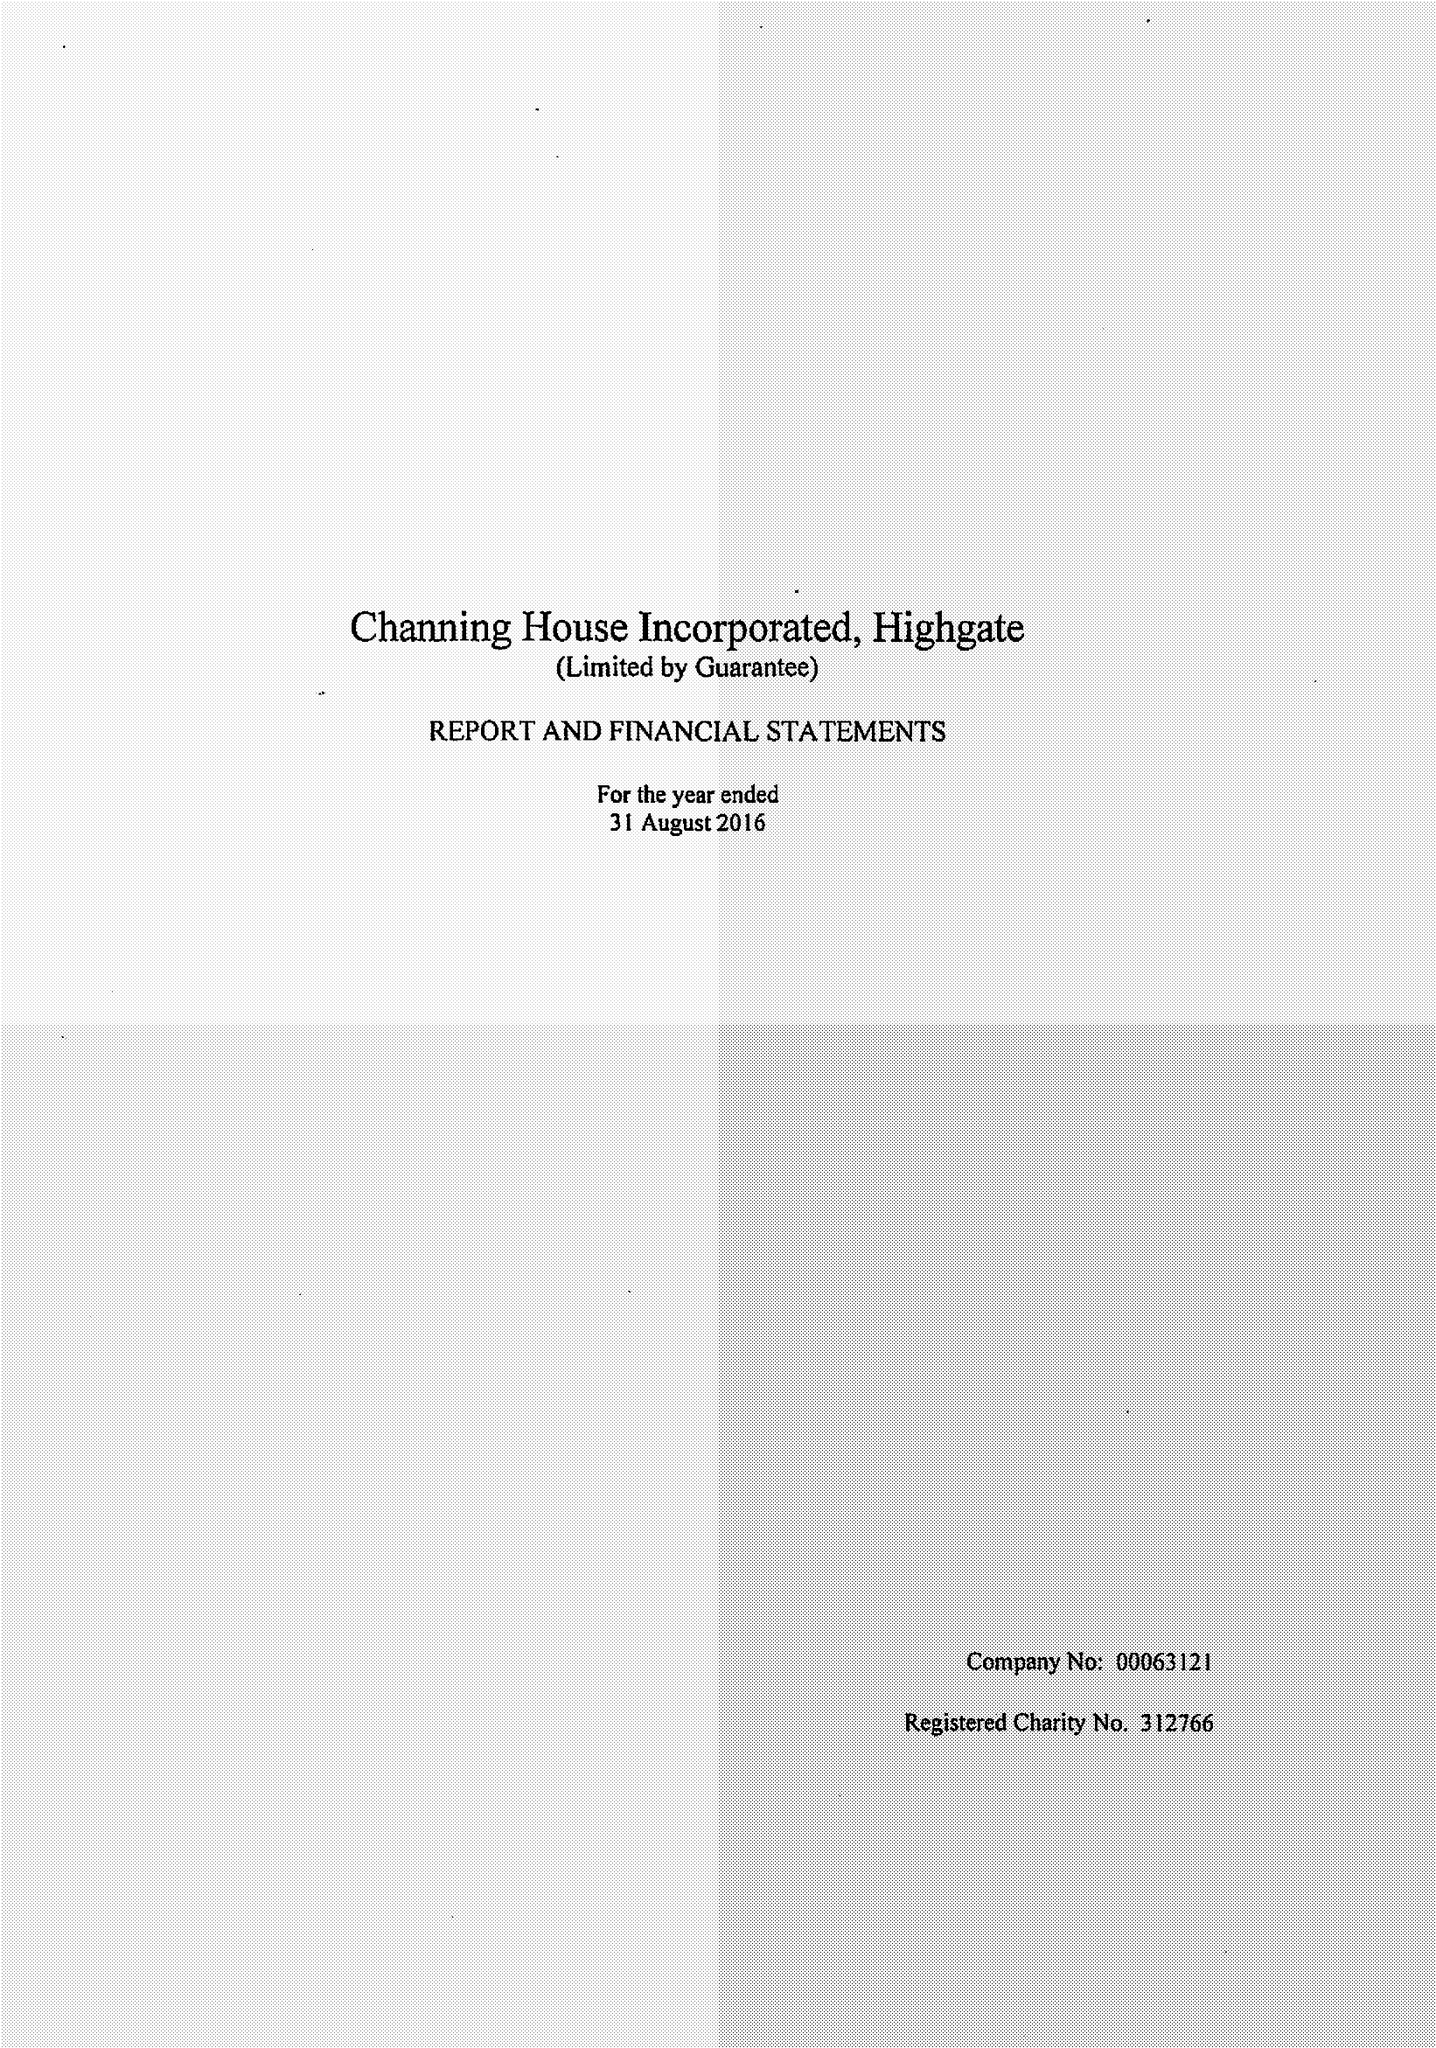What is the value for the charity_name?
Answer the question using a single word or phrase. Channing House Inc. 